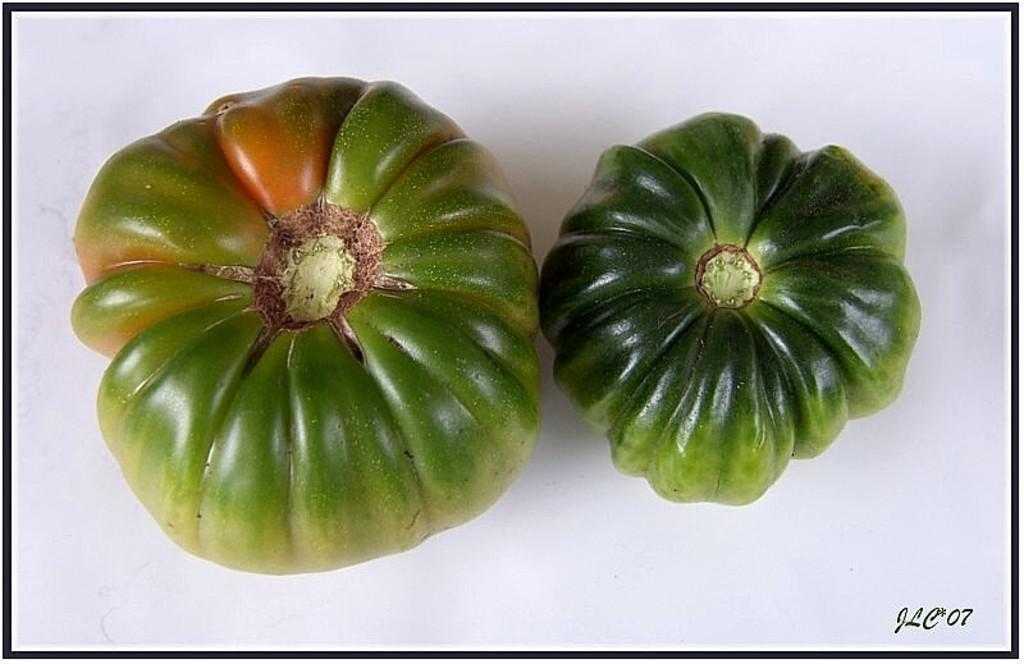How would you summarize this image in a sentence or two? In this image, we can see vegetables on the white surface. On the right side bottom corner, there is a watermark. Here we can see black color borders in the image. 